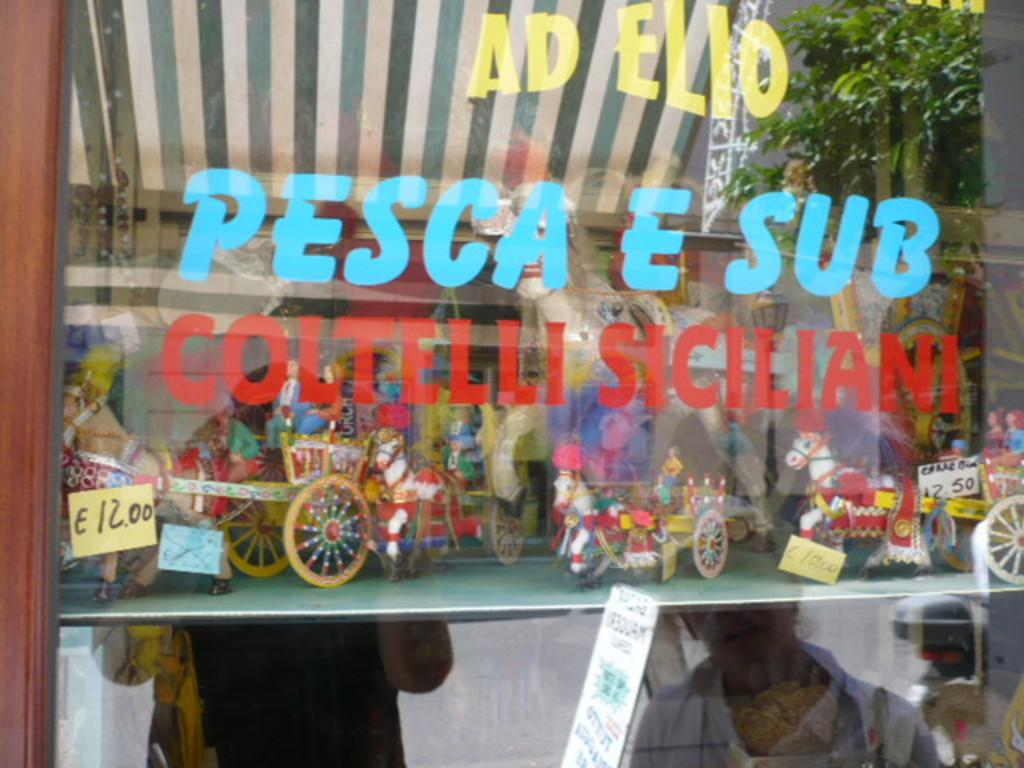What object is in front of the store in the image? There is a glass in front of the store in the image. What can be seen on the glass of the store? The reflection of two people is visible on the glass of the store. What type of mint is growing on the grass near the store in the image? There is no mint or grass present in the image; it only features a glass and the reflection of two people. 